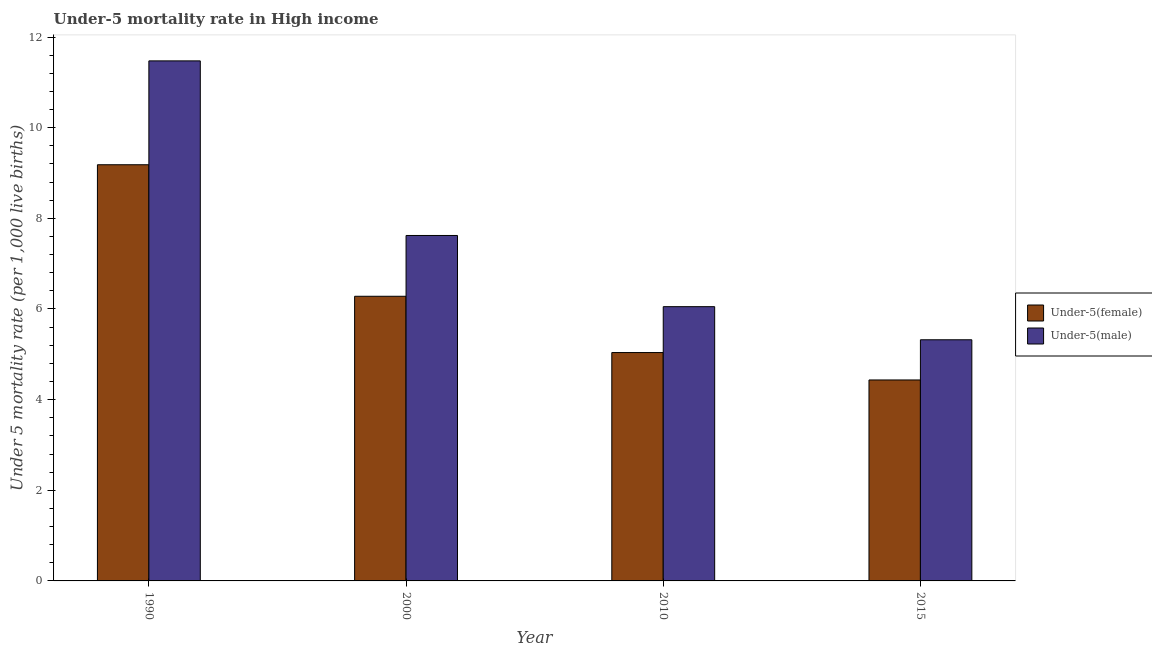How many different coloured bars are there?
Make the answer very short. 2. How many groups of bars are there?
Provide a short and direct response. 4. How many bars are there on the 4th tick from the left?
Provide a succinct answer. 2. What is the label of the 2nd group of bars from the left?
Your answer should be compact. 2000. What is the under-5 male mortality rate in 2010?
Keep it short and to the point. 6.05. Across all years, what is the maximum under-5 male mortality rate?
Your answer should be compact. 11.47. Across all years, what is the minimum under-5 male mortality rate?
Your answer should be compact. 5.32. In which year was the under-5 male mortality rate maximum?
Provide a succinct answer. 1990. In which year was the under-5 female mortality rate minimum?
Give a very brief answer. 2015. What is the total under-5 male mortality rate in the graph?
Keep it short and to the point. 30.47. What is the difference between the under-5 female mortality rate in 1990 and that in 2000?
Offer a very short reply. 2.9. What is the difference between the under-5 female mortality rate in 2000 and the under-5 male mortality rate in 2010?
Your answer should be compact. 1.24. What is the average under-5 male mortality rate per year?
Your answer should be compact. 7.62. What is the ratio of the under-5 female mortality rate in 2000 to that in 2010?
Provide a short and direct response. 1.25. Is the under-5 female mortality rate in 1990 less than that in 2015?
Provide a succinct answer. No. Is the difference between the under-5 female mortality rate in 2000 and 2010 greater than the difference between the under-5 male mortality rate in 2000 and 2010?
Offer a terse response. No. What is the difference between the highest and the second highest under-5 female mortality rate?
Provide a short and direct response. 2.9. What is the difference between the highest and the lowest under-5 male mortality rate?
Give a very brief answer. 6.15. Is the sum of the under-5 male mortality rate in 2000 and 2015 greater than the maximum under-5 female mortality rate across all years?
Give a very brief answer. Yes. What does the 2nd bar from the left in 2000 represents?
Your answer should be very brief. Under-5(male). What does the 1st bar from the right in 2015 represents?
Your answer should be compact. Under-5(male). Are the values on the major ticks of Y-axis written in scientific E-notation?
Your answer should be very brief. No. Does the graph contain grids?
Your answer should be very brief. No. Where does the legend appear in the graph?
Offer a very short reply. Center right. How many legend labels are there?
Make the answer very short. 2. What is the title of the graph?
Offer a terse response. Under-5 mortality rate in High income. Does "Merchandise imports" appear as one of the legend labels in the graph?
Make the answer very short. No. What is the label or title of the X-axis?
Your response must be concise. Year. What is the label or title of the Y-axis?
Your response must be concise. Under 5 mortality rate (per 1,0 live births). What is the Under 5 mortality rate (per 1,000 live births) of Under-5(female) in 1990?
Your answer should be compact. 9.18. What is the Under 5 mortality rate (per 1,000 live births) of Under-5(male) in 1990?
Keep it short and to the point. 11.47. What is the Under 5 mortality rate (per 1,000 live births) of Under-5(female) in 2000?
Ensure brevity in your answer.  6.28. What is the Under 5 mortality rate (per 1,000 live births) of Under-5(male) in 2000?
Offer a terse response. 7.62. What is the Under 5 mortality rate (per 1,000 live births) in Under-5(female) in 2010?
Make the answer very short. 5.04. What is the Under 5 mortality rate (per 1,000 live births) in Under-5(male) in 2010?
Your answer should be very brief. 6.05. What is the Under 5 mortality rate (per 1,000 live births) in Under-5(female) in 2015?
Your answer should be very brief. 4.43. What is the Under 5 mortality rate (per 1,000 live births) in Under-5(male) in 2015?
Provide a succinct answer. 5.32. Across all years, what is the maximum Under 5 mortality rate (per 1,000 live births) in Under-5(female)?
Keep it short and to the point. 9.18. Across all years, what is the maximum Under 5 mortality rate (per 1,000 live births) in Under-5(male)?
Provide a succinct answer. 11.47. Across all years, what is the minimum Under 5 mortality rate (per 1,000 live births) of Under-5(female)?
Provide a succinct answer. 4.43. Across all years, what is the minimum Under 5 mortality rate (per 1,000 live births) of Under-5(male)?
Give a very brief answer. 5.32. What is the total Under 5 mortality rate (per 1,000 live births) of Under-5(female) in the graph?
Provide a succinct answer. 24.94. What is the total Under 5 mortality rate (per 1,000 live births) of Under-5(male) in the graph?
Ensure brevity in your answer.  30.47. What is the difference between the Under 5 mortality rate (per 1,000 live births) in Under-5(female) in 1990 and that in 2000?
Provide a succinct answer. 2.9. What is the difference between the Under 5 mortality rate (per 1,000 live births) in Under-5(male) in 1990 and that in 2000?
Offer a very short reply. 3.85. What is the difference between the Under 5 mortality rate (per 1,000 live births) in Under-5(female) in 1990 and that in 2010?
Offer a very short reply. 4.14. What is the difference between the Under 5 mortality rate (per 1,000 live births) of Under-5(male) in 1990 and that in 2010?
Offer a terse response. 5.42. What is the difference between the Under 5 mortality rate (per 1,000 live births) in Under-5(female) in 1990 and that in 2015?
Your response must be concise. 4.75. What is the difference between the Under 5 mortality rate (per 1,000 live births) of Under-5(male) in 1990 and that in 2015?
Provide a short and direct response. 6.15. What is the difference between the Under 5 mortality rate (per 1,000 live births) of Under-5(female) in 2000 and that in 2010?
Provide a short and direct response. 1.24. What is the difference between the Under 5 mortality rate (per 1,000 live births) of Under-5(male) in 2000 and that in 2010?
Your answer should be compact. 1.57. What is the difference between the Under 5 mortality rate (per 1,000 live births) in Under-5(female) in 2000 and that in 2015?
Provide a succinct answer. 1.85. What is the difference between the Under 5 mortality rate (per 1,000 live births) in Under-5(male) in 2000 and that in 2015?
Give a very brief answer. 2.3. What is the difference between the Under 5 mortality rate (per 1,000 live births) of Under-5(female) in 2010 and that in 2015?
Your answer should be compact. 0.6. What is the difference between the Under 5 mortality rate (per 1,000 live births) in Under-5(male) in 2010 and that in 2015?
Provide a succinct answer. 0.73. What is the difference between the Under 5 mortality rate (per 1,000 live births) in Under-5(female) in 1990 and the Under 5 mortality rate (per 1,000 live births) in Under-5(male) in 2000?
Offer a very short reply. 1.56. What is the difference between the Under 5 mortality rate (per 1,000 live births) in Under-5(female) in 1990 and the Under 5 mortality rate (per 1,000 live births) in Under-5(male) in 2010?
Provide a short and direct response. 3.13. What is the difference between the Under 5 mortality rate (per 1,000 live births) in Under-5(female) in 1990 and the Under 5 mortality rate (per 1,000 live births) in Under-5(male) in 2015?
Offer a very short reply. 3.86. What is the difference between the Under 5 mortality rate (per 1,000 live births) in Under-5(female) in 2000 and the Under 5 mortality rate (per 1,000 live births) in Under-5(male) in 2010?
Your response must be concise. 0.23. What is the difference between the Under 5 mortality rate (per 1,000 live births) of Under-5(female) in 2000 and the Under 5 mortality rate (per 1,000 live births) of Under-5(male) in 2015?
Offer a terse response. 0.96. What is the difference between the Under 5 mortality rate (per 1,000 live births) in Under-5(female) in 2010 and the Under 5 mortality rate (per 1,000 live births) in Under-5(male) in 2015?
Your response must be concise. -0.28. What is the average Under 5 mortality rate (per 1,000 live births) of Under-5(female) per year?
Your answer should be compact. 6.23. What is the average Under 5 mortality rate (per 1,000 live births) of Under-5(male) per year?
Your answer should be very brief. 7.62. In the year 1990, what is the difference between the Under 5 mortality rate (per 1,000 live births) of Under-5(female) and Under 5 mortality rate (per 1,000 live births) of Under-5(male)?
Offer a terse response. -2.29. In the year 2000, what is the difference between the Under 5 mortality rate (per 1,000 live births) of Under-5(female) and Under 5 mortality rate (per 1,000 live births) of Under-5(male)?
Offer a very short reply. -1.34. In the year 2010, what is the difference between the Under 5 mortality rate (per 1,000 live births) of Under-5(female) and Under 5 mortality rate (per 1,000 live births) of Under-5(male)?
Your answer should be compact. -1.01. In the year 2015, what is the difference between the Under 5 mortality rate (per 1,000 live births) in Under-5(female) and Under 5 mortality rate (per 1,000 live births) in Under-5(male)?
Your response must be concise. -0.89. What is the ratio of the Under 5 mortality rate (per 1,000 live births) in Under-5(female) in 1990 to that in 2000?
Your answer should be compact. 1.46. What is the ratio of the Under 5 mortality rate (per 1,000 live births) in Under-5(male) in 1990 to that in 2000?
Offer a very short reply. 1.51. What is the ratio of the Under 5 mortality rate (per 1,000 live births) of Under-5(female) in 1990 to that in 2010?
Provide a short and direct response. 1.82. What is the ratio of the Under 5 mortality rate (per 1,000 live births) in Under-5(male) in 1990 to that in 2010?
Give a very brief answer. 1.9. What is the ratio of the Under 5 mortality rate (per 1,000 live births) in Under-5(female) in 1990 to that in 2015?
Offer a terse response. 2.07. What is the ratio of the Under 5 mortality rate (per 1,000 live births) of Under-5(male) in 1990 to that in 2015?
Keep it short and to the point. 2.16. What is the ratio of the Under 5 mortality rate (per 1,000 live births) in Under-5(female) in 2000 to that in 2010?
Offer a terse response. 1.25. What is the ratio of the Under 5 mortality rate (per 1,000 live births) of Under-5(male) in 2000 to that in 2010?
Ensure brevity in your answer.  1.26. What is the ratio of the Under 5 mortality rate (per 1,000 live births) of Under-5(female) in 2000 to that in 2015?
Provide a succinct answer. 1.42. What is the ratio of the Under 5 mortality rate (per 1,000 live births) of Under-5(male) in 2000 to that in 2015?
Offer a terse response. 1.43. What is the ratio of the Under 5 mortality rate (per 1,000 live births) of Under-5(female) in 2010 to that in 2015?
Make the answer very short. 1.14. What is the ratio of the Under 5 mortality rate (per 1,000 live births) of Under-5(male) in 2010 to that in 2015?
Give a very brief answer. 1.14. What is the difference between the highest and the second highest Under 5 mortality rate (per 1,000 live births) in Under-5(female)?
Your answer should be compact. 2.9. What is the difference between the highest and the second highest Under 5 mortality rate (per 1,000 live births) in Under-5(male)?
Your response must be concise. 3.85. What is the difference between the highest and the lowest Under 5 mortality rate (per 1,000 live births) of Under-5(female)?
Keep it short and to the point. 4.75. What is the difference between the highest and the lowest Under 5 mortality rate (per 1,000 live births) of Under-5(male)?
Your answer should be compact. 6.15. 